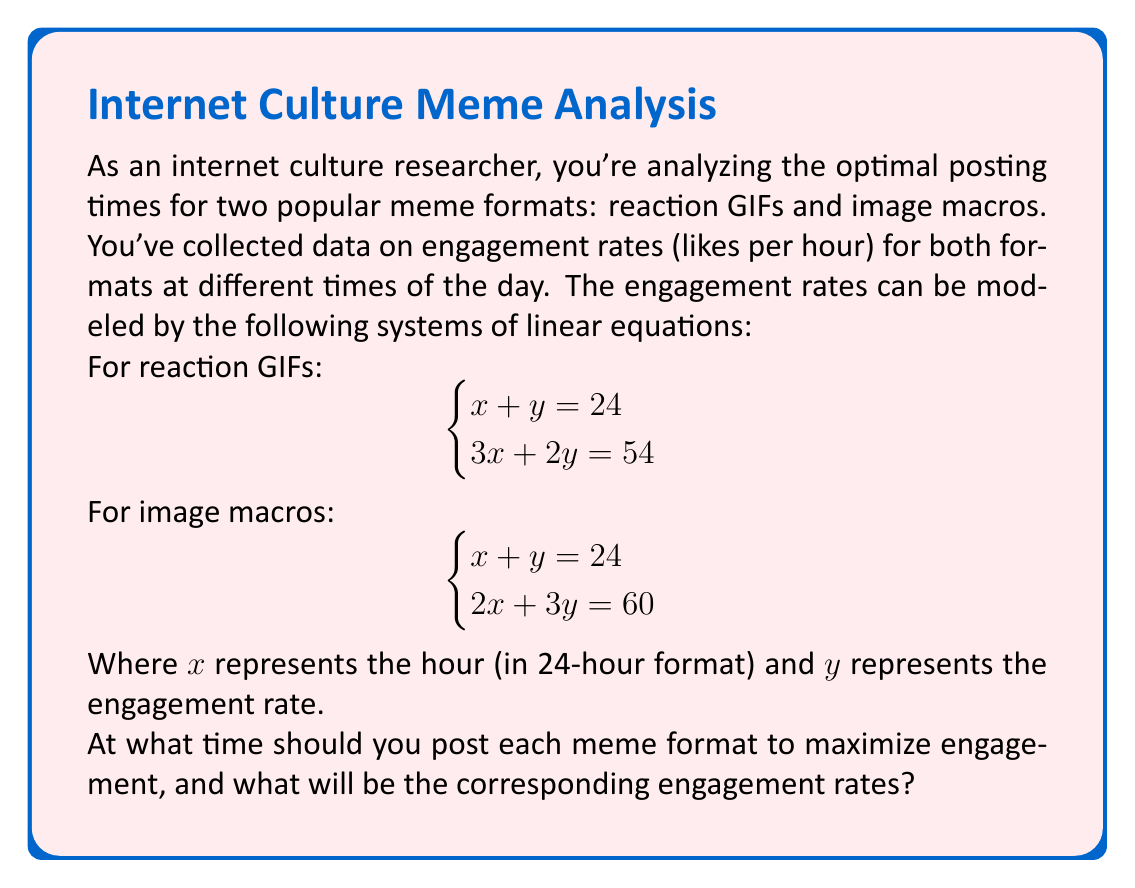Can you answer this question? Let's solve this problem step by step for each meme format:

1. Reaction GIFs:
   We have the system of equations:
   $$\begin{cases} x + y = 24 \\ 3x + 2y = 54 \end{cases}$$

   a) Multiply the first equation by 2: $2x + 2y = 48$
   b) Subtract this from the second equation:
      $3x + 2y = 54$
      $-(2x + 2y = 48)$
      $x = 6$
   c) Substitute $x = 6$ into $x + y = 24$:
      $6 + y = 24$
      $y = 18$

   Therefore, for reaction GIFs, $x = 6$ (6:00 AM) and $y = 18$ likes per hour.

2. Image Macros:
   We have the system of equations:
   $$\begin{cases} x + y = 24 \\ 2x + 3y = 60 \end{cases}$$

   a) Multiply the first equation by 2: $2x + 2y = 48$
   b) Subtract this from the second equation:
      $2x + 3y = 60$
      $-(2x + 2y = 48)$
      $y = 12$
   c) Substitute $y = 12$ into $x + y = 24$:
      $x + 12 = 24$
      $x = 12$

   Therefore, for image macros, $x = 12$ (12:00 PM) and $y = 12$ likes per hour.
Answer: Reaction GIFs: Post at 6:00 AM for 18 likes per hour.
Image Macros: Post at 12:00 PM for 12 likes per hour. 